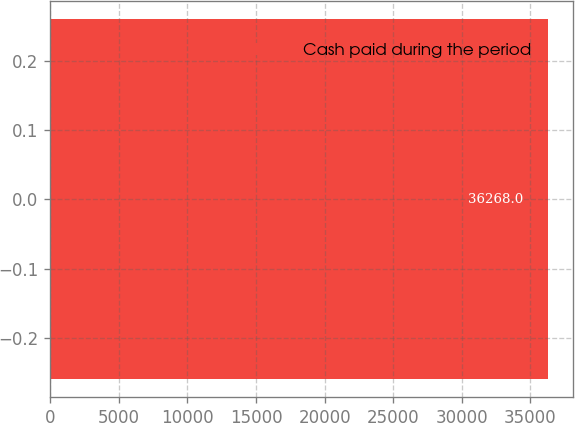<chart> <loc_0><loc_0><loc_500><loc_500><bar_chart><fcel>Cash paid during the period<nl><fcel>36268<nl></chart> 